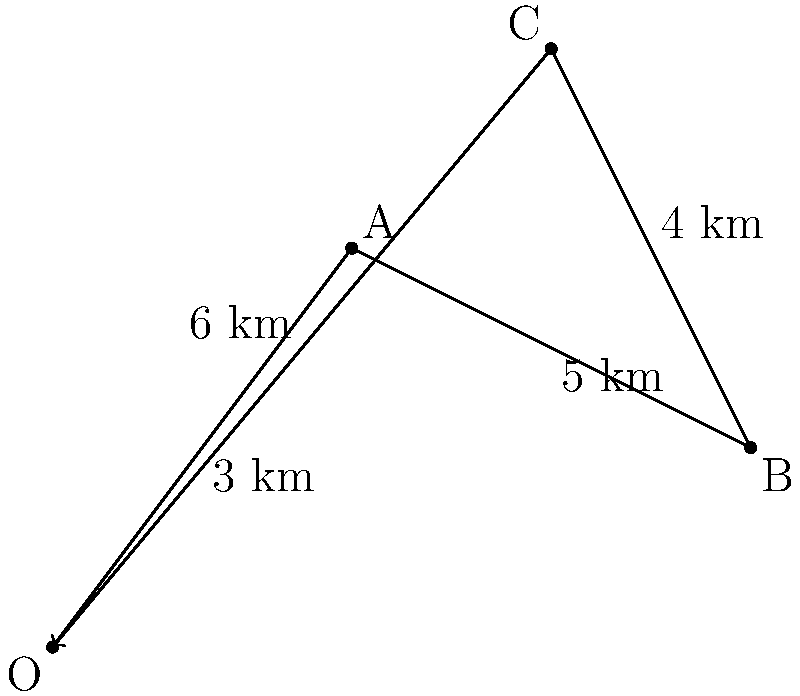As an ecotourism guide in Odisha, you're designing a new nature trail. The trail starts at point O and connects three attractions A, B, and C before returning to O. Given the vectors OA = 3i + 4j km, AB = 4i - 2j km, and BC = -2i + 4j km, what is the displacement vector from C back to O to complete the trail? Let's approach this step-by-step:

1) We know that in a closed path, the sum of all vectors should be zero:
   $$\vec{OA} + \vec{AB} + \vec{BC} + \vec{CO} = \vec{0}$$

2) We're given:
   $$\vec{OA} = 3\vec{i} + 4\vec{j}$$
   $$\vec{AB} = 4\vec{i} - 2\vec{j}$$
   $$\vec{BC} = -2\vec{i} + 4\vec{j}$$

3) We need to find $\vec{CO}$. Let's call it $\vec{x}$:
   $$\vec{OA} + \vec{AB} + \vec{BC} + \vec{x} = \vec{0}$$

4) Substituting the known vectors:
   $$(3\vec{i} + 4\vec{j}) + (4\vec{i} - 2\vec{j}) + (-2\vec{i} + 4\vec{j}) + \vec{x} = \vec{0}$$

5) Combining like terms:
   $$(5\vec{i} + 6\vec{j}) + \vec{x} = \vec{0}$$

6) Solving for $\vec{x}$:
   $$\vec{x} = -(5\vec{i} + 6\vec{j}) = -5\vec{i} - 6\vec{j}$$

7) Therefore, $\vec{CO} = -5\vec{i} - 6\vec{j}$

This vector represents the displacement from C back to O, completing the trail.
Answer: $-5\vec{i} - 6\vec{j}$ km 